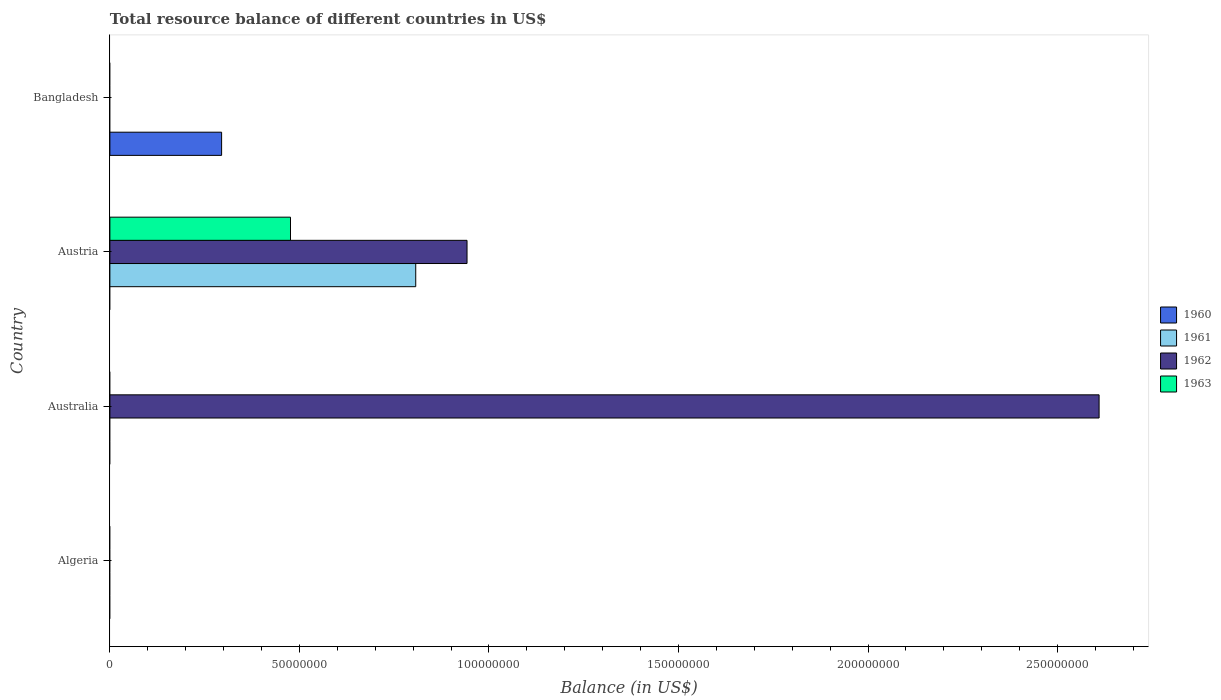How many different coloured bars are there?
Give a very brief answer. 4. Are the number of bars per tick equal to the number of legend labels?
Provide a succinct answer. No. What is the label of the 3rd group of bars from the top?
Keep it short and to the point. Australia. In how many cases, is the number of bars for a given country not equal to the number of legend labels?
Provide a succinct answer. 4. Across all countries, what is the maximum total resource balance in 1961?
Ensure brevity in your answer.  8.07e+07. Across all countries, what is the minimum total resource balance in 1962?
Offer a very short reply. 0. What is the total total resource balance in 1961 in the graph?
Your answer should be compact. 8.07e+07. What is the difference between the total resource balance in 1962 in Australia and that in Austria?
Your response must be concise. 1.67e+08. What is the difference between the total resource balance in 1961 in Austria and the total resource balance in 1963 in Australia?
Make the answer very short. 8.07e+07. What is the average total resource balance in 1962 per country?
Make the answer very short. 8.88e+07. What is the difference between the total resource balance in 1962 and total resource balance in 1961 in Austria?
Make the answer very short. 1.35e+07. In how many countries, is the total resource balance in 1962 greater than 210000000 US$?
Offer a very short reply. 1. What is the difference between the highest and the lowest total resource balance in 1963?
Give a very brief answer. 4.76e+07. Is it the case that in every country, the sum of the total resource balance in 1961 and total resource balance in 1963 is greater than the sum of total resource balance in 1960 and total resource balance in 1962?
Your answer should be very brief. No. What is the difference between two consecutive major ticks on the X-axis?
Your response must be concise. 5.00e+07. Are the values on the major ticks of X-axis written in scientific E-notation?
Make the answer very short. No. Does the graph contain grids?
Your answer should be very brief. No. How many legend labels are there?
Your answer should be very brief. 4. How are the legend labels stacked?
Provide a short and direct response. Vertical. What is the title of the graph?
Offer a very short reply. Total resource balance of different countries in US$. What is the label or title of the X-axis?
Keep it short and to the point. Balance (in US$). What is the label or title of the Y-axis?
Offer a very short reply. Country. What is the Balance (in US$) in 1960 in Algeria?
Make the answer very short. 0. What is the Balance (in US$) in 1961 in Algeria?
Your response must be concise. 0. What is the Balance (in US$) in 1962 in Algeria?
Make the answer very short. 0. What is the Balance (in US$) in 1960 in Australia?
Offer a terse response. 0. What is the Balance (in US$) in 1961 in Australia?
Make the answer very short. 0. What is the Balance (in US$) of 1962 in Australia?
Ensure brevity in your answer.  2.61e+08. What is the Balance (in US$) in 1963 in Australia?
Offer a terse response. 0. What is the Balance (in US$) in 1960 in Austria?
Offer a terse response. 0. What is the Balance (in US$) in 1961 in Austria?
Your response must be concise. 8.07e+07. What is the Balance (in US$) of 1962 in Austria?
Keep it short and to the point. 9.42e+07. What is the Balance (in US$) in 1963 in Austria?
Offer a very short reply. 4.76e+07. What is the Balance (in US$) in 1960 in Bangladesh?
Provide a short and direct response. 2.95e+07. Across all countries, what is the maximum Balance (in US$) in 1960?
Your answer should be very brief. 2.95e+07. Across all countries, what is the maximum Balance (in US$) in 1961?
Provide a succinct answer. 8.07e+07. Across all countries, what is the maximum Balance (in US$) of 1962?
Offer a very short reply. 2.61e+08. Across all countries, what is the maximum Balance (in US$) of 1963?
Offer a very short reply. 4.76e+07. Across all countries, what is the minimum Balance (in US$) in 1961?
Your answer should be very brief. 0. What is the total Balance (in US$) in 1960 in the graph?
Your response must be concise. 2.95e+07. What is the total Balance (in US$) in 1961 in the graph?
Offer a terse response. 8.07e+07. What is the total Balance (in US$) of 1962 in the graph?
Give a very brief answer. 3.55e+08. What is the total Balance (in US$) in 1963 in the graph?
Your answer should be compact. 4.76e+07. What is the difference between the Balance (in US$) of 1962 in Australia and that in Austria?
Your answer should be compact. 1.67e+08. What is the difference between the Balance (in US$) in 1962 in Australia and the Balance (in US$) in 1963 in Austria?
Your response must be concise. 2.13e+08. What is the average Balance (in US$) in 1960 per country?
Your answer should be very brief. 7.37e+06. What is the average Balance (in US$) in 1961 per country?
Keep it short and to the point. 2.02e+07. What is the average Balance (in US$) of 1962 per country?
Give a very brief answer. 8.88e+07. What is the average Balance (in US$) in 1963 per country?
Offer a terse response. 1.19e+07. What is the difference between the Balance (in US$) in 1961 and Balance (in US$) in 1962 in Austria?
Ensure brevity in your answer.  -1.35e+07. What is the difference between the Balance (in US$) in 1961 and Balance (in US$) in 1963 in Austria?
Give a very brief answer. 3.30e+07. What is the difference between the Balance (in US$) in 1962 and Balance (in US$) in 1963 in Austria?
Provide a short and direct response. 4.66e+07. What is the ratio of the Balance (in US$) of 1962 in Australia to that in Austria?
Offer a very short reply. 2.77. What is the difference between the highest and the lowest Balance (in US$) in 1960?
Offer a very short reply. 2.95e+07. What is the difference between the highest and the lowest Balance (in US$) of 1961?
Provide a short and direct response. 8.07e+07. What is the difference between the highest and the lowest Balance (in US$) of 1962?
Your answer should be compact. 2.61e+08. What is the difference between the highest and the lowest Balance (in US$) of 1963?
Ensure brevity in your answer.  4.76e+07. 